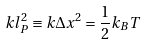<formula> <loc_0><loc_0><loc_500><loc_500>k l ^ { 2 } _ { P } \equiv k \Delta x ^ { 2 } = \frac { 1 } { 2 } k _ { B } T</formula> 